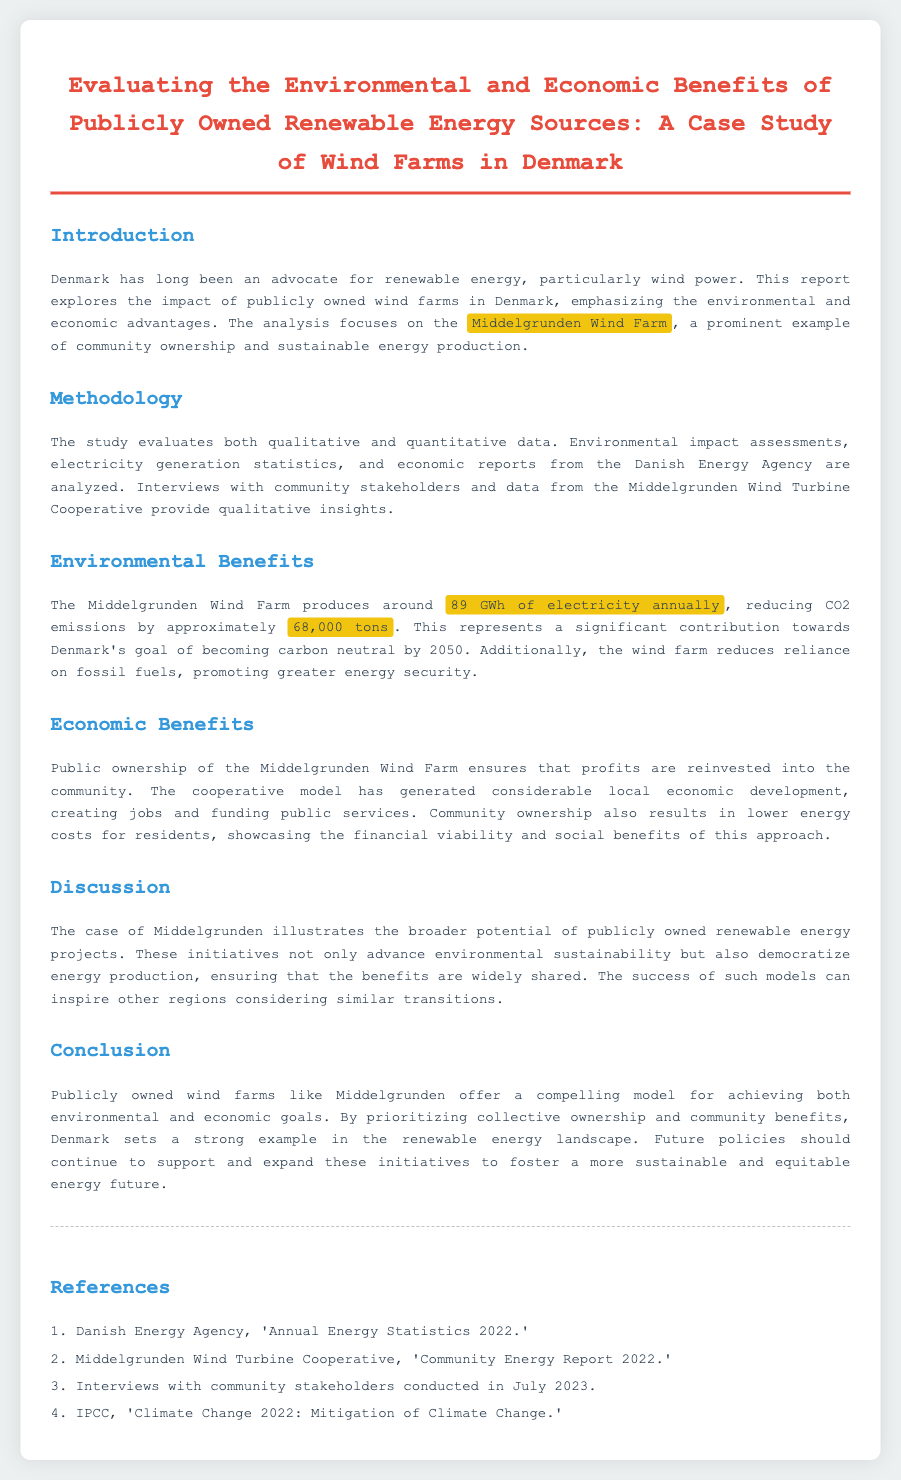What is the main focus of the report? The report explores the impact of publicly owned wind farms in Denmark, emphasizing the environmental and economic advantages.
Answer: public ownership of wind farms How much electricity does the Middelgrunden Wind Farm produce annually? The document states that the Middelgrunden Wind Farm produces around 89 GWh of electricity annually.
Answer: 89 GWh What is the approximate reduction in CO2 emissions from the Middelgrunden Wind Farm? It is mentioned that the wind farm reduces CO2 emissions by approximately 68,000 tons.
Answer: 68,000 tons What model has generated considerable local economic development? The cooperative model has generated considerable local economic development.
Answer: cooperative model What are the future policy recommendations mentioned in the report? The report concludes that future policies should continue to support and expand these initiatives.
Answer: support and expand these initiatives Which wind farm is cited as an example in the case study? The Middelgrunden Wind Farm is cited as an example in the case study.
Answer: Middelgrunden Wind Farm What is the environmental goal for Denmark by 2050? The document states that the goal is to become carbon neutral by 2050.
Answer: carbon neutral by 2050 Which organization provided the annual energy statistics? The Danish Energy Agency provided the annual energy statistics.
Answer: Danish Energy Agency What ensures lower energy costs for residents in this model? Community ownership results in lower energy costs for residents, highlighting financial viability.
Answer: community ownership 